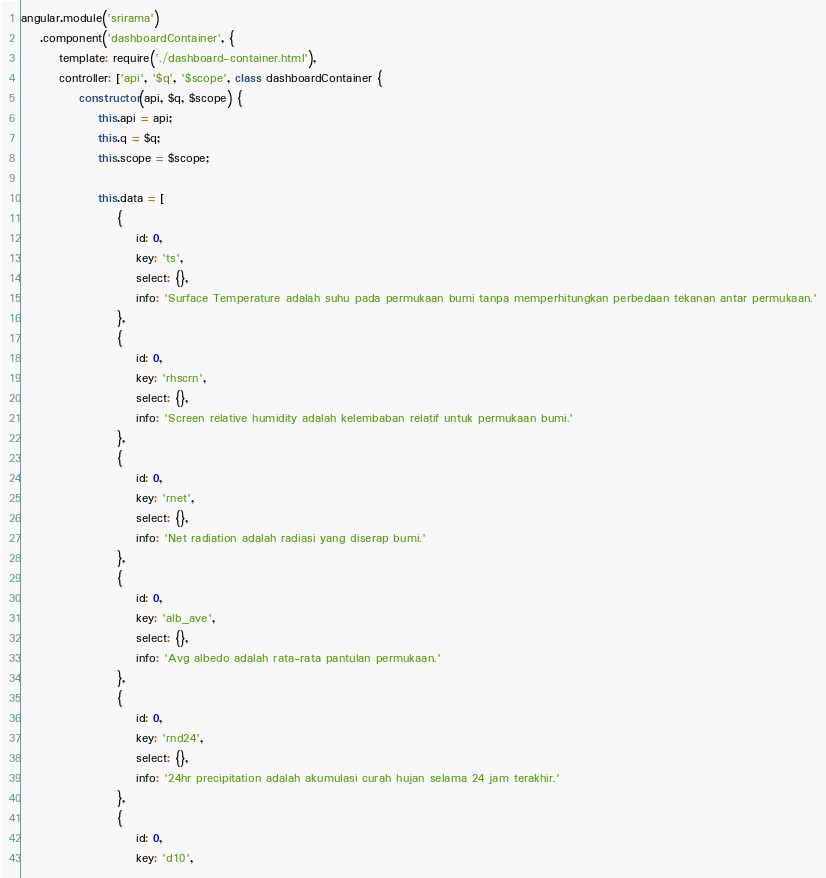Convert code to text. <code><loc_0><loc_0><loc_500><loc_500><_JavaScript_>angular.module('srirama')
    .component('dashboardContainer', {
        template: require('./dashboard-container.html'),
        controller: ['api', '$q', '$scope', class dashboardContainer {
            constructor(api, $q, $scope) {
                this.api = api;
                this.q = $q;
                this.scope = $scope;

                this.data = [
                    {
                        id: 0,
                        key: 'ts',
                        select: {},
                        info: 'Surface Temperature adalah suhu pada permukaan bumi tanpa memperhitungkan perbedaan tekanan antar permukaan.'
                    },
                    {
                        id: 0,
                        key: 'rhscrn',
                        select: {},
                        info: 'Screen relative humidity adalah kelembaban relatif untuk permukaan bumi.'
                    },
                    {
                        id: 0,
                        key: 'rnet',
                        select: {},
                        info: 'Net radiation adalah radiasi yang diserap bumi.'
                    },
                    {
                        id: 0,
                        key: 'alb_ave',
                        select: {},
                        info: 'Avg albedo adalah rata-rata pantulan permukaan.'
                    },
                    {
                        id: 0,
                        key: 'rnd24',
                        select: {},
                        info: '24hr precipitation adalah akumulasi curah hujan selama 24 jam terakhir.'
                    },
                    {
                        id: 0,
                        key: 'd10',</code> 